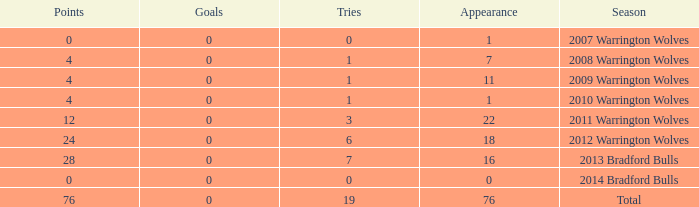What is the lowest appearance when goals is more than 0? None. 